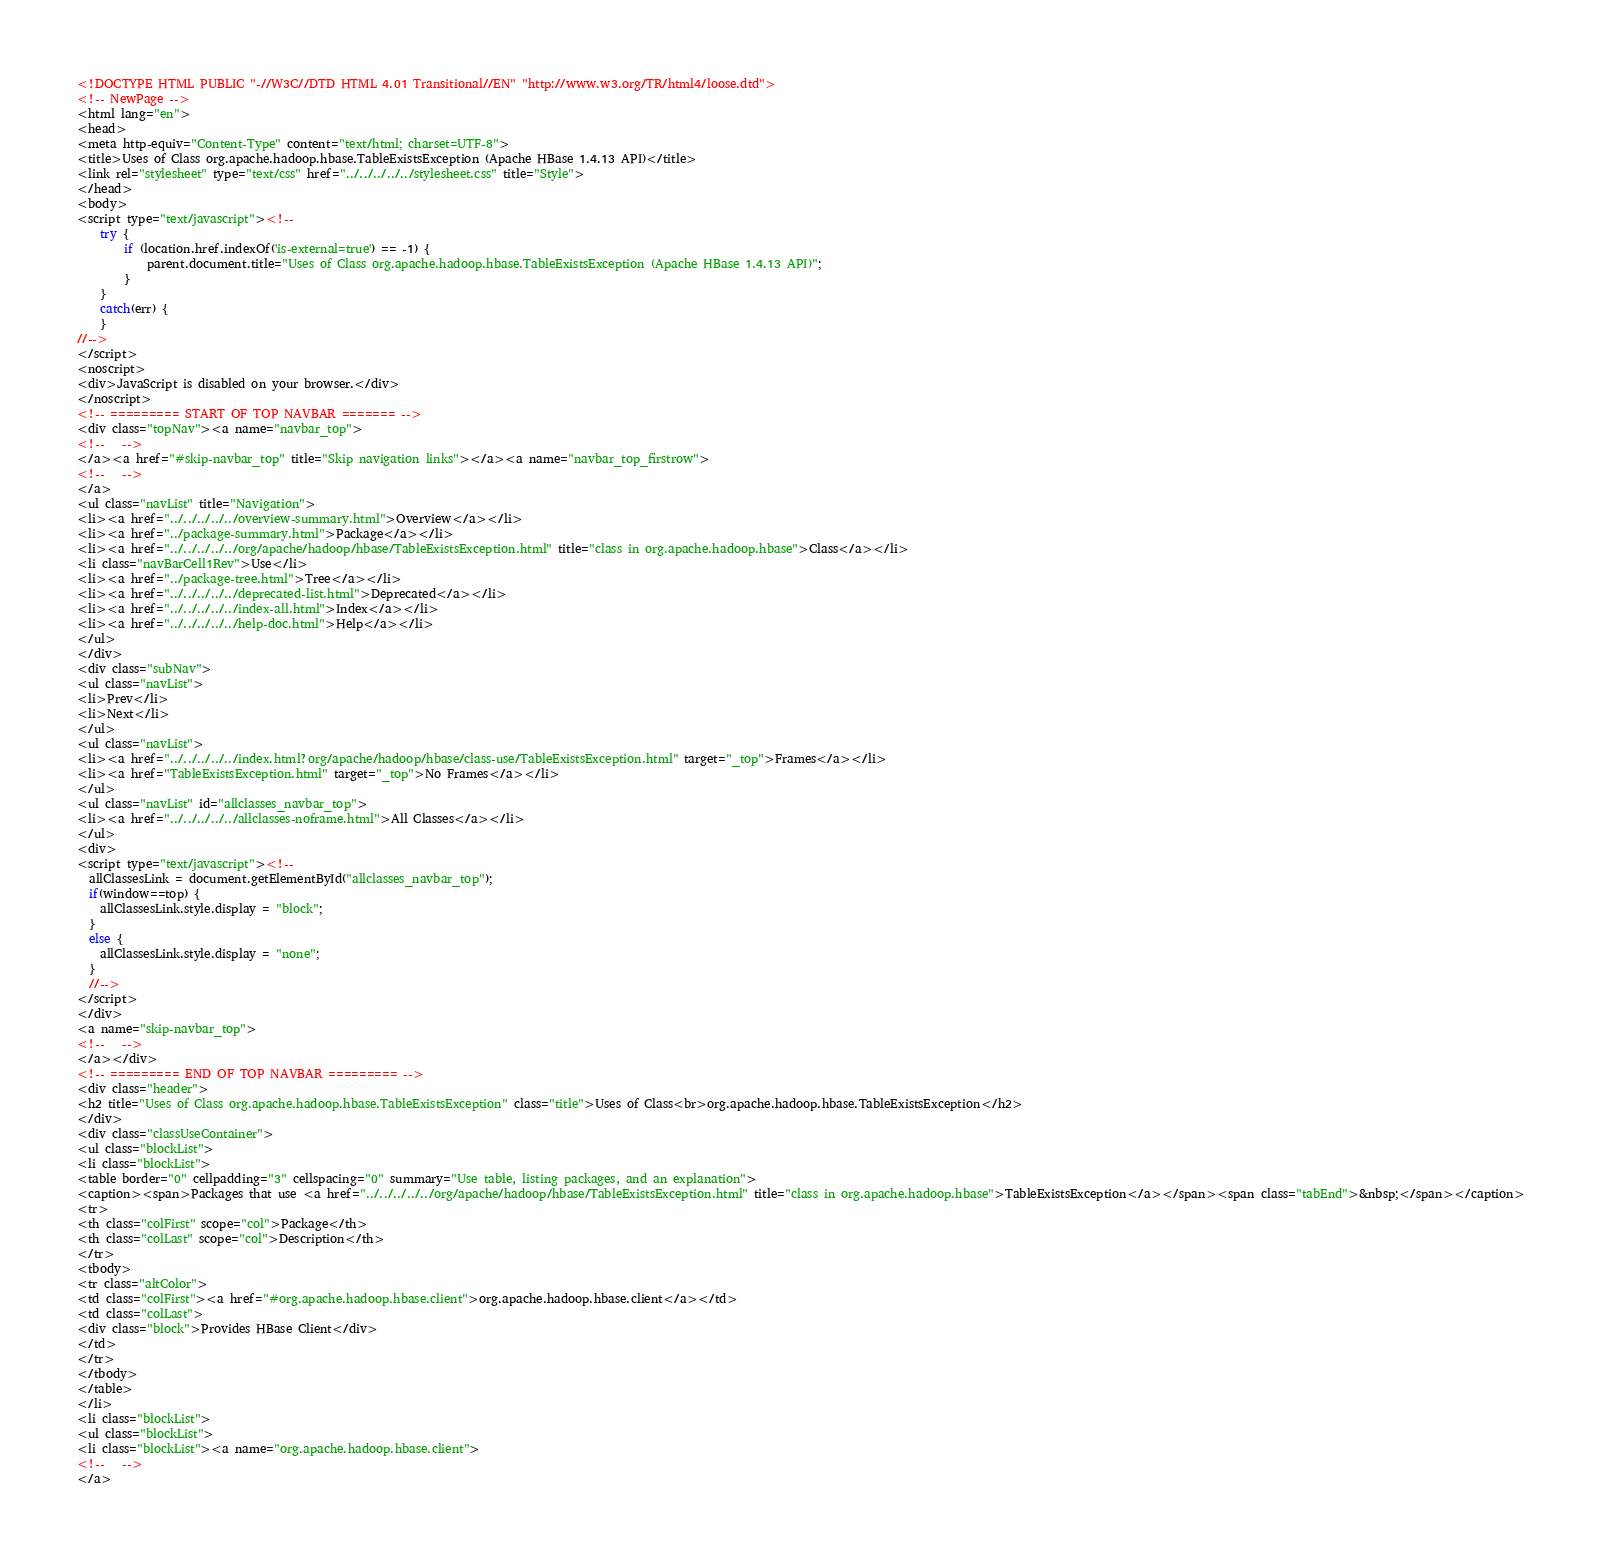<code> <loc_0><loc_0><loc_500><loc_500><_HTML_><!DOCTYPE HTML PUBLIC "-//W3C//DTD HTML 4.01 Transitional//EN" "http://www.w3.org/TR/html4/loose.dtd">
<!-- NewPage -->
<html lang="en">
<head>
<meta http-equiv="Content-Type" content="text/html; charset=UTF-8">
<title>Uses of Class org.apache.hadoop.hbase.TableExistsException (Apache HBase 1.4.13 API)</title>
<link rel="stylesheet" type="text/css" href="../../../../../stylesheet.css" title="Style">
</head>
<body>
<script type="text/javascript"><!--
    try {
        if (location.href.indexOf('is-external=true') == -1) {
            parent.document.title="Uses of Class org.apache.hadoop.hbase.TableExistsException (Apache HBase 1.4.13 API)";
        }
    }
    catch(err) {
    }
//-->
</script>
<noscript>
<div>JavaScript is disabled on your browser.</div>
</noscript>
<!-- ========= START OF TOP NAVBAR ======= -->
<div class="topNav"><a name="navbar_top">
<!--   -->
</a><a href="#skip-navbar_top" title="Skip navigation links"></a><a name="navbar_top_firstrow">
<!--   -->
</a>
<ul class="navList" title="Navigation">
<li><a href="../../../../../overview-summary.html">Overview</a></li>
<li><a href="../package-summary.html">Package</a></li>
<li><a href="../../../../../org/apache/hadoop/hbase/TableExistsException.html" title="class in org.apache.hadoop.hbase">Class</a></li>
<li class="navBarCell1Rev">Use</li>
<li><a href="../package-tree.html">Tree</a></li>
<li><a href="../../../../../deprecated-list.html">Deprecated</a></li>
<li><a href="../../../../../index-all.html">Index</a></li>
<li><a href="../../../../../help-doc.html">Help</a></li>
</ul>
</div>
<div class="subNav">
<ul class="navList">
<li>Prev</li>
<li>Next</li>
</ul>
<ul class="navList">
<li><a href="../../../../../index.html?org/apache/hadoop/hbase/class-use/TableExistsException.html" target="_top">Frames</a></li>
<li><a href="TableExistsException.html" target="_top">No Frames</a></li>
</ul>
<ul class="navList" id="allclasses_navbar_top">
<li><a href="../../../../../allclasses-noframe.html">All Classes</a></li>
</ul>
<div>
<script type="text/javascript"><!--
  allClassesLink = document.getElementById("allclasses_navbar_top");
  if(window==top) {
    allClassesLink.style.display = "block";
  }
  else {
    allClassesLink.style.display = "none";
  }
  //-->
</script>
</div>
<a name="skip-navbar_top">
<!--   -->
</a></div>
<!-- ========= END OF TOP NAVBAR ========= -->
<div class="header">
<h2 title="Uses of Class org.apache.hadoop.hbase.TableExistsException" class="title">Uses of Class<br>org.apache.hadoop.hbase.TableExistsException</h2>
</div>
<div class="classUseContainer">
<ul class="blockList">
<li class="blockList">
<table border="0" cellpadding="3" cellspacing="0" summary="Use table, listing packages, and an explanation">
<caption><span>Packages that use <a href="../../../../../org/apache/hadoop/hbase/TableExistsException.html" title="class in org.apache.hadoop.hbase">TableExistsException</a></span><span class="tabEnd">&nbsp;</span></caption>
<tr>
<th class="colFirst" scope="col">Package</th>
<th class="colLast" scope="col">Description</th>
</tr>
<tbody>
<tr class="altColor">
<td class="colFirst"><a href="#org.apache.hadoop.hbase.client">org.apache.hadoop.hbase.client</a></td>
<td class="colLast">
<div class="block">Provides HBase Client</div>
</td>
</tr>
</tbody>
</table>
</li>
<li class="blockList">
<ul class="blockList">
<li class="blockList"><a name="org.apache.hadoop.hbase.client">
<!--   -->
</a></code> 